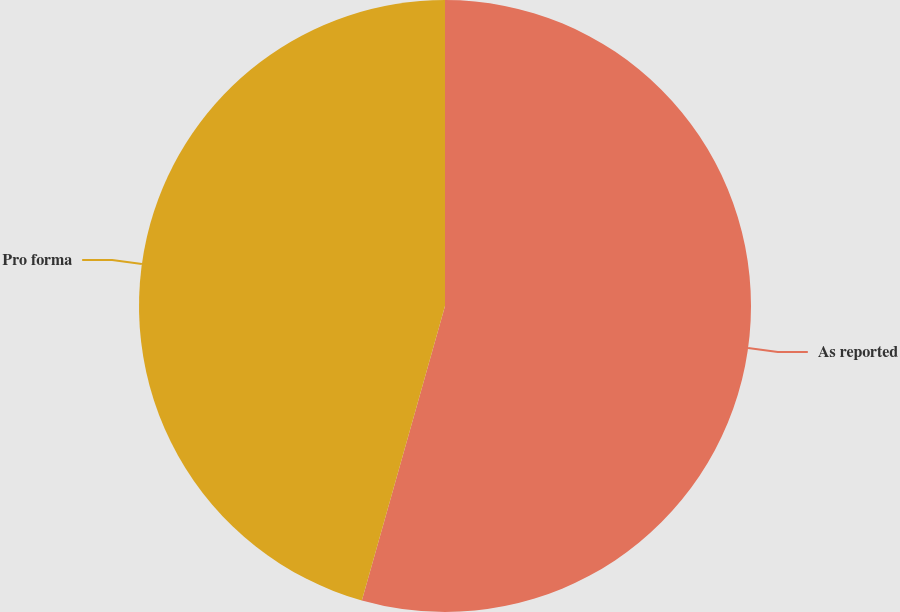Convert chart. <chart><loc_0><loc_0><loc_500><loc_500><pie_chart><fcel>As reported<fcel>Pro forma<nl><fcel>54.38%<fcel>45.62%<nl></chart> 